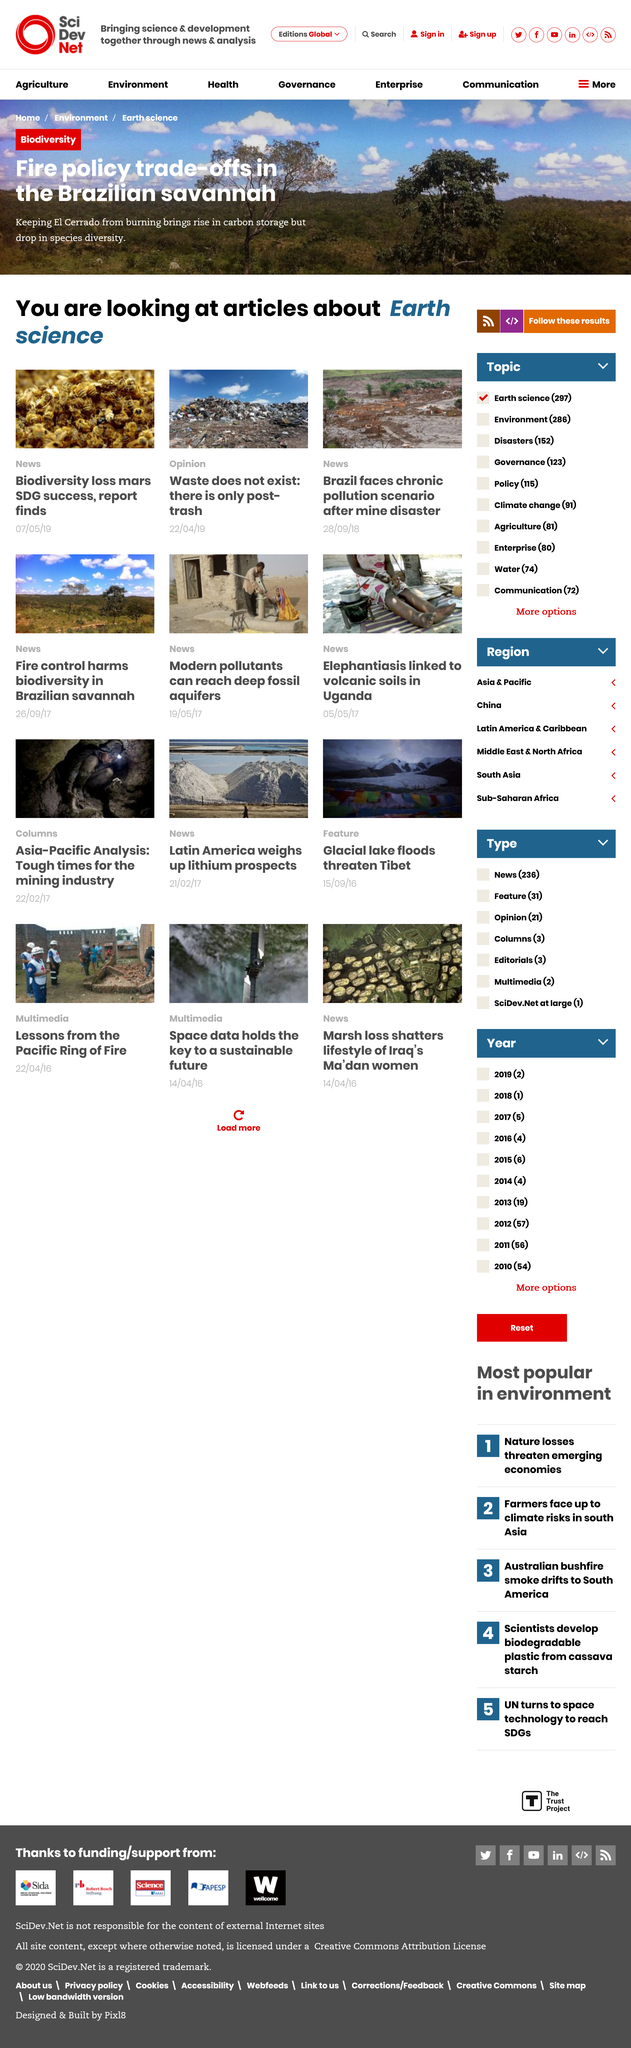Specify some key components in this picture. The act of stopping the burning of El Cerrado, in order to prevent it from burning, has the disadvantage of resulting in a decrease in species diversity. The title of the opinion piece is "Waste does not exist: there is only post-trash. Stopping the burning of the Brazilian savannah would lead to an increase in carbon storage, which is the main advantage of such an action. 